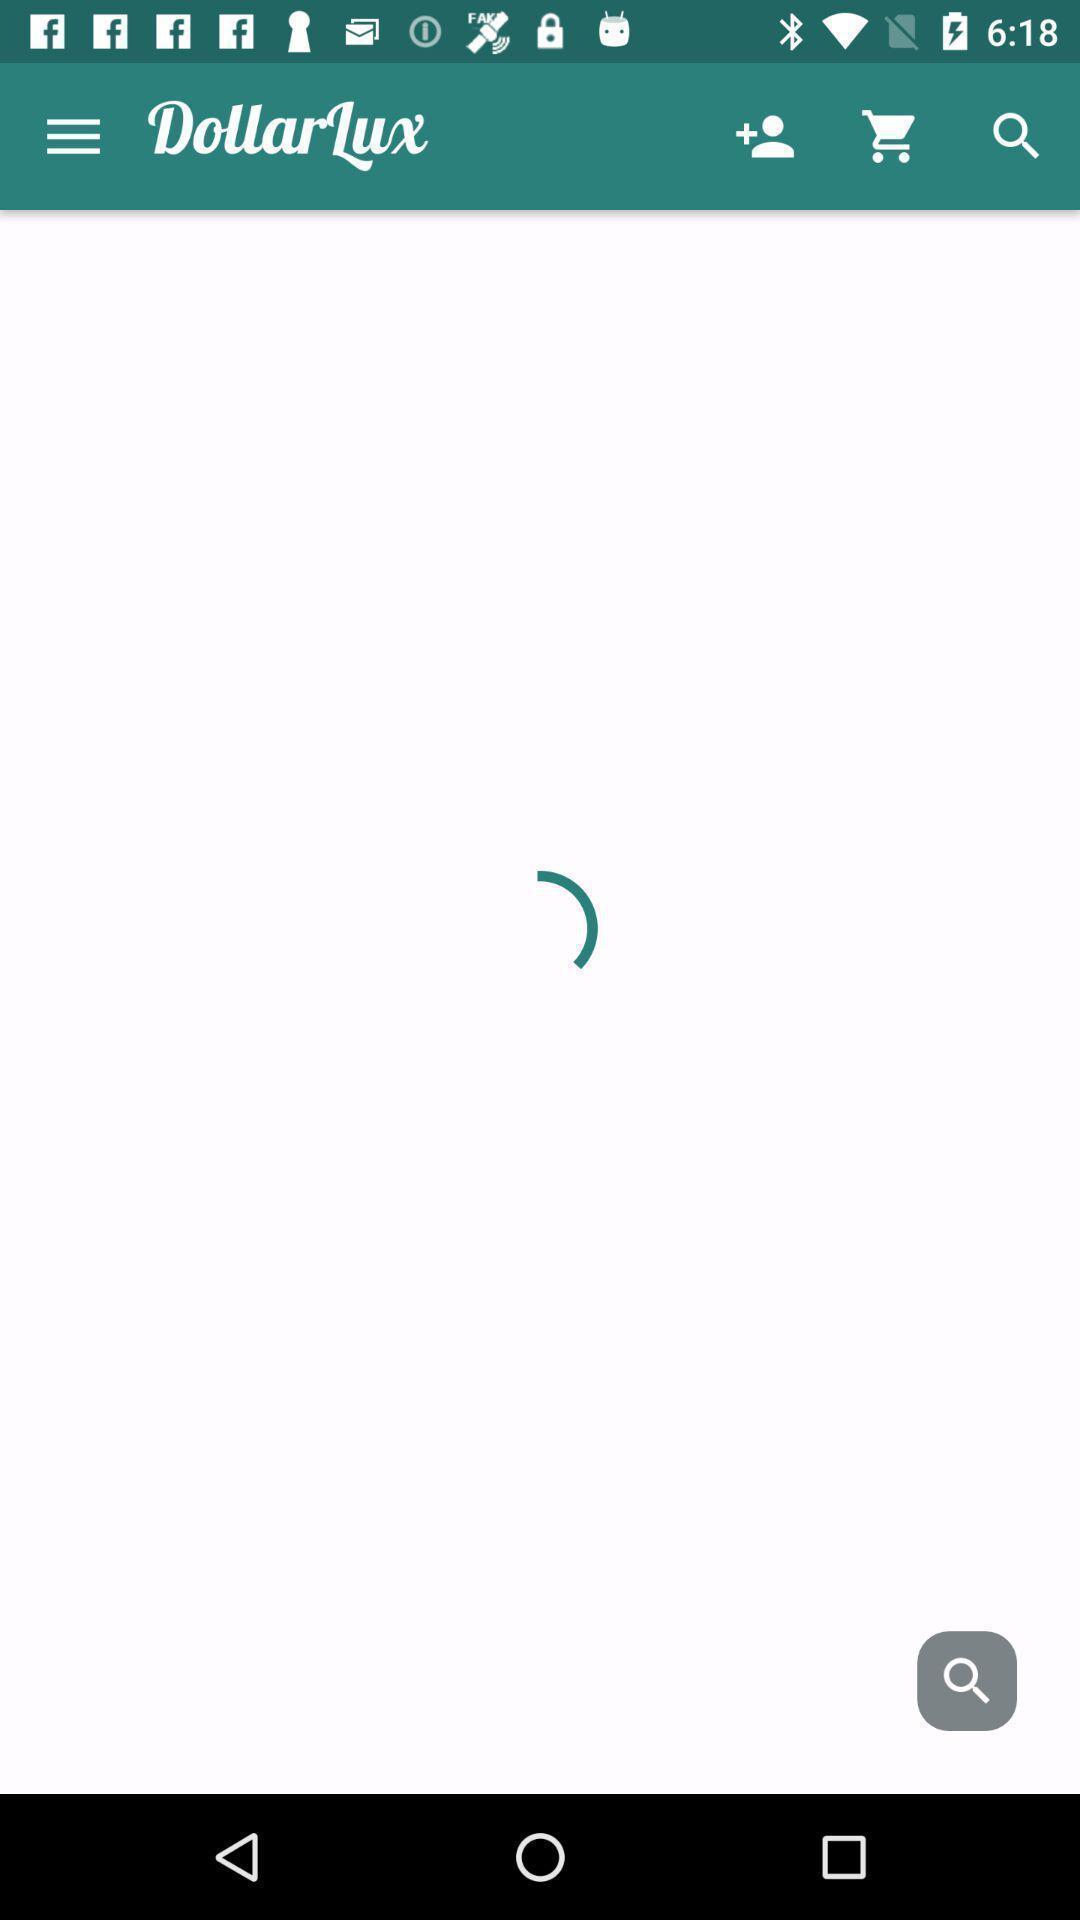What details can you identify in this image? Shopping page. 